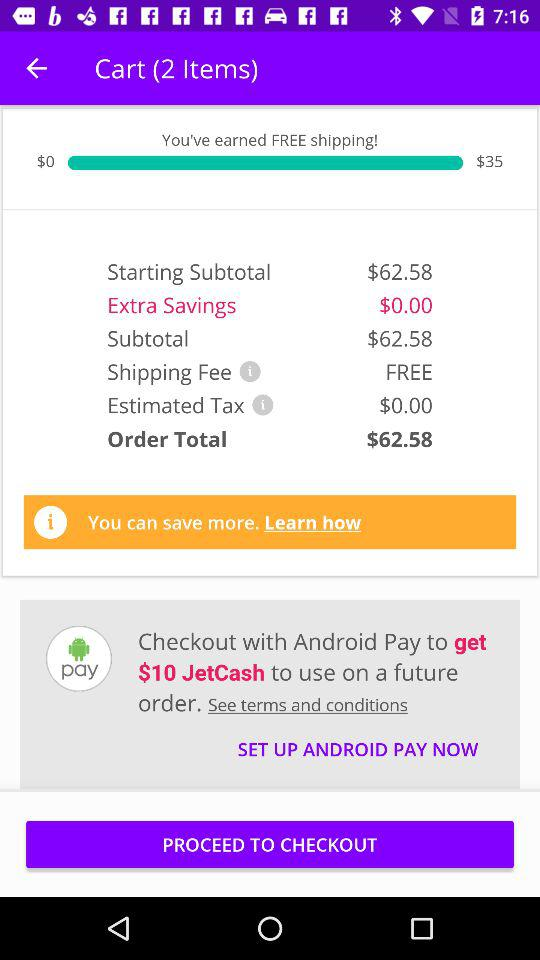How many total items are in the cart? The total number of items in the cart is 2. 